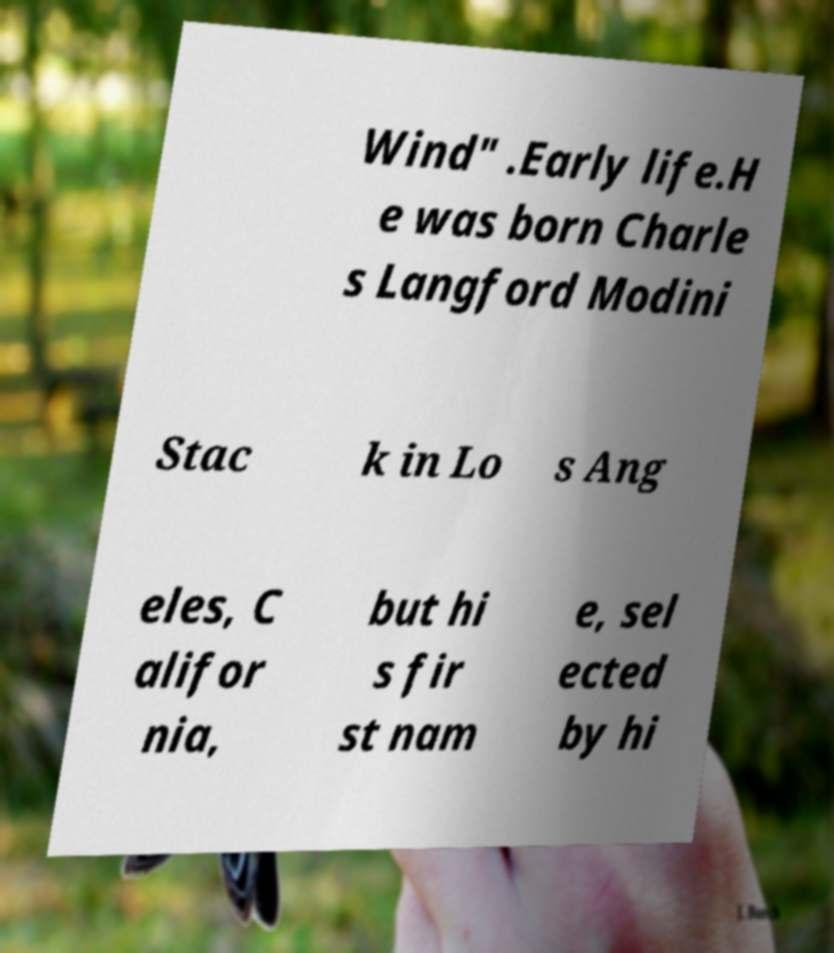Could you assist in decoding the text presented in this image and type it out clearly? Wind" .Early life.H e was born Charle s Langford Modini Stac k in Lo s Ang eles, C alifor nia, but hi s fir st nam e, sel ected by hi 